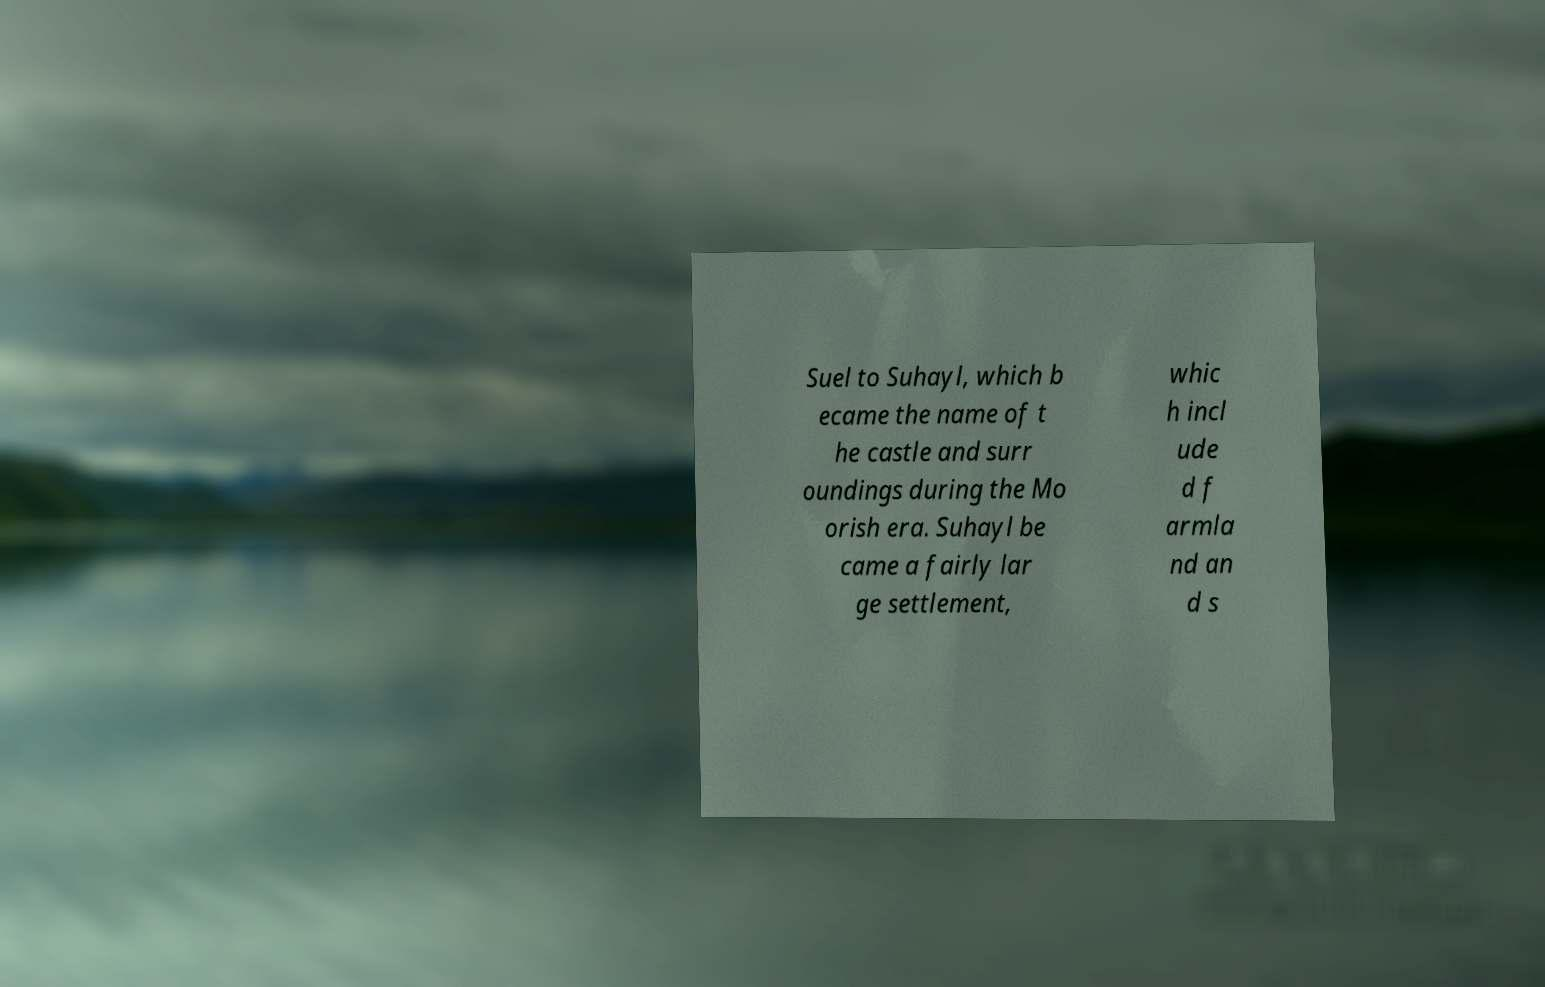What messages or text are displayed in this image? I need them in a readable, typed format. Suel to Suhayl, which b ecame the name of t he castle and surr oundings during the Mo orish era. Suhayl be came a fairly lar ge settlement, whic h incl ude d f armla nd an d s 